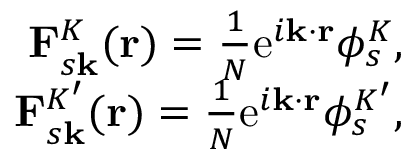Convert formula to latex. <formula><loc_0><loc_0><loc_500><loc_500>\begin{array} { r } { F _ { s k } ^ { K } ( r ) = \frac { 1 } { N } e ^ { i k \cdot r } \phi _ { s } ^ { K } , } \\ { F _ { s k } ^ { K ^ { \prime } } ( r ) = \frac { 1 } { N } e ^ { i k \cdot r } \phi _ { s } ^ { K ^ { \prime } } , } \end{array}</formula> 